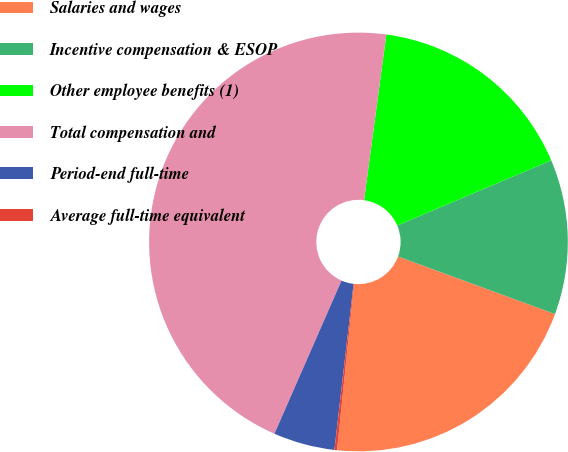Convert chart. <chart><loc_0><loc_0><loc_500><loc_500><pie_chart><fcel>Salaries and wages<fcel>Incentive compensation & ESOP<fcel>Other employee benefits (1)<fcel>Total compensation and<fcel>Period-end full-time<fcel>Average full-time equivalent<nl><fcel>21.04%<fcel>11.97%<fcel>16.5%<fcel>45.56%<fcel>4.74%<fcel>0.2%<nl></chart> 